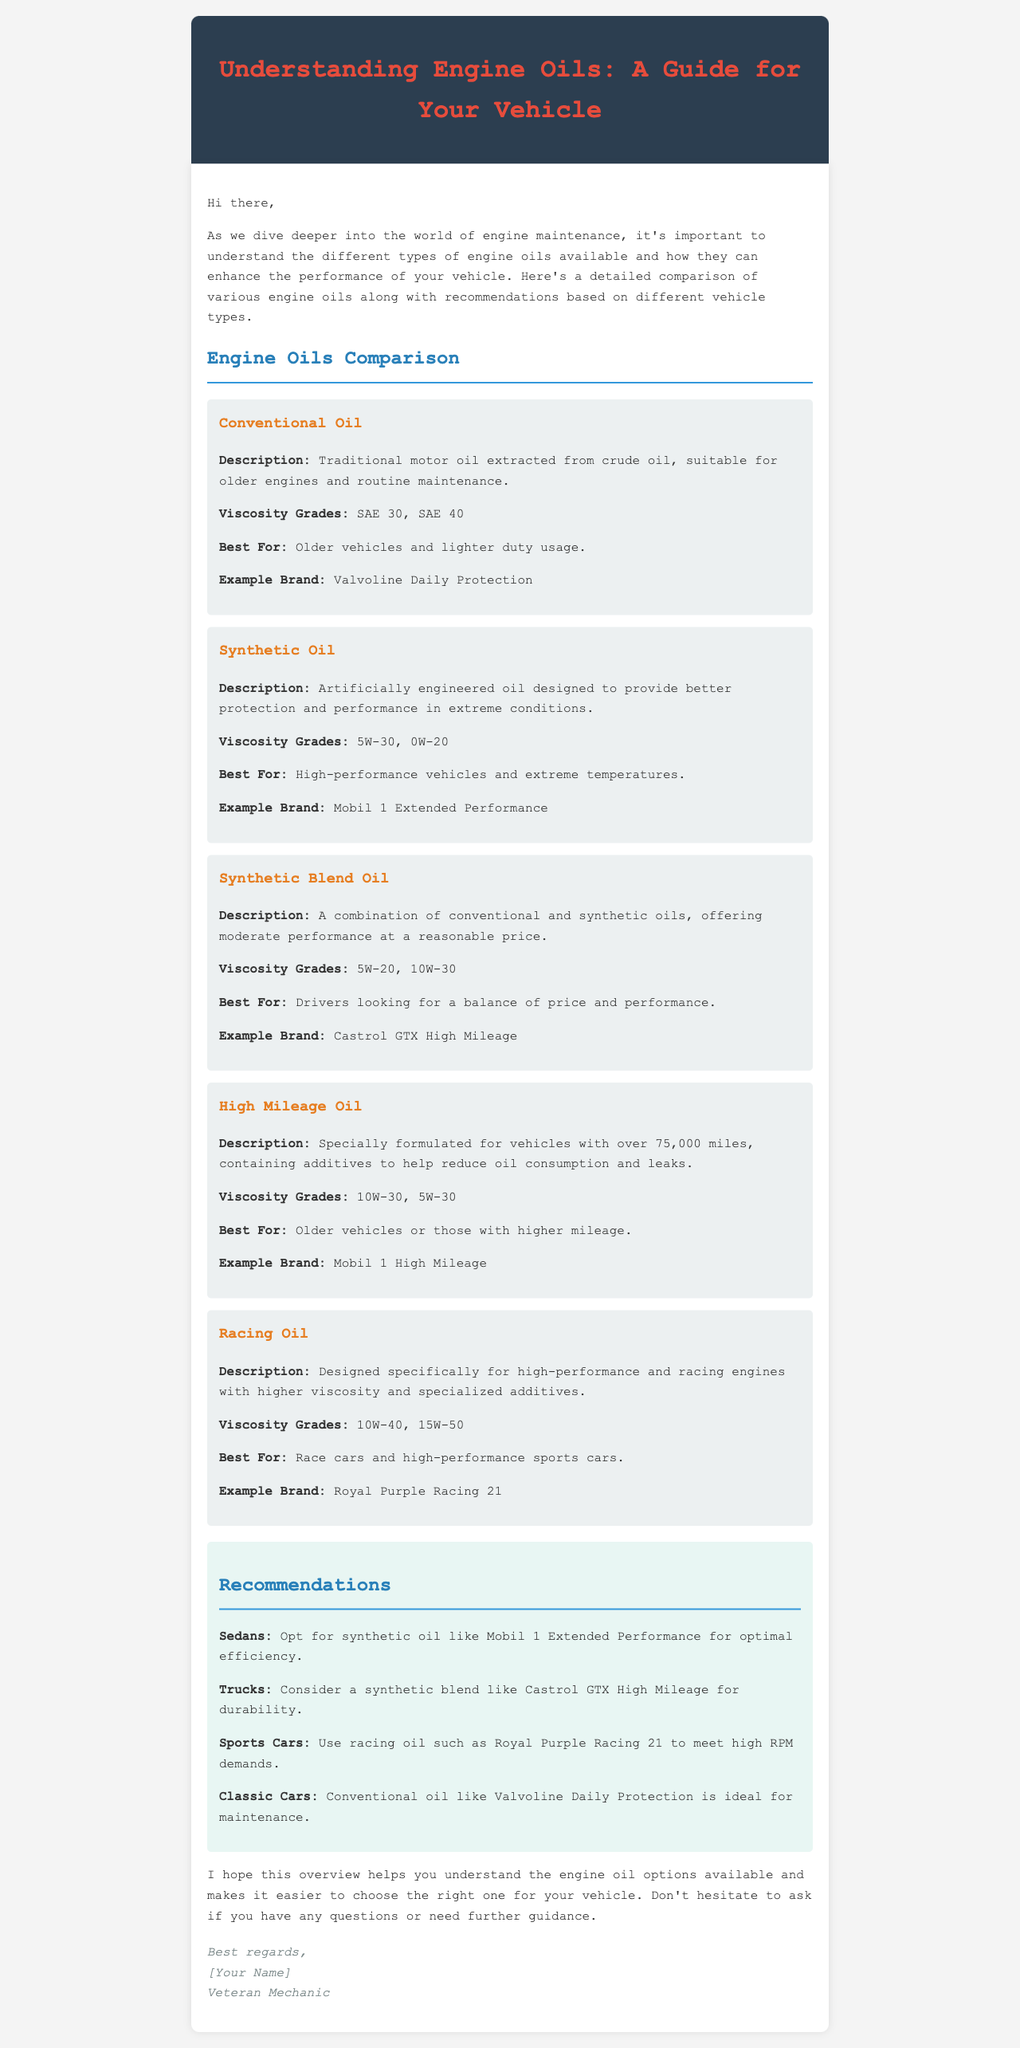What is the title of the document? The title of the document is located in the heading section, which clearly states the topic it covers.
Answer: Understanding Engine Oils: A Guide for Your Vehicle What oil is recommended for trucks? The recommendation section specifies the type of oil suggested for trucks based on durability.
Answer: Synthetic blend like Castrol GTX High Mileage Which oil type is suitable for older vehicles? The document indicates that certain oils are best for older vehicles, detailing specifically what type they are.
Answer: High Mileage Oil What is a common viscosity grade for racing oil? The comparison section includes viscosity grades for each type of engine oil, including those suitable for racing.
Answer: 10W-40 What is the description of synthetic oil? The document provides descriptions for each type of engine oil, including synthetic oil.
Answer: Artificially engineered oil designed to provide better protection and performance in extreme conditions Which brand is mentioned for high mileage oil? The document lists example brands for each oil type, providing specific brands for high mileage oil.
Answer: Mobil 1 High Mileage What oil type is best for classic cars? The recommendations section explains which oil type is most suitable for classic cars based on maintenance needs.
Answer: Conventional oil like Valvoline Daily Protection What viscosity grade is associated with conventional oil? The document specifies viscosity grades for conventional oil under its description section.
Answer: SAE 30, SAE 40 